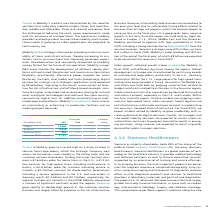According to Siemens Ag's financial document, What was the reason for the increase in the Orders at Mobility? grew to a record high on a sharp increase in volume from large orders, which the Strategic Company won across the businesses, most notably in the rolling stock and the customer services businesses.. The document states: "Orders at Mobility grew to a record high on a sharp increase in volume from large orders, which the Strategic Company won across the businesses, most ..." Also, What was the reason for the increase in the Revenue? Revenue grew slightly as double-digit growth in the customer services business was largely offset by a decline in the rail infrastructure business.. The document states: "umber of significant contracts across the regions. Revenue grew slightly as double-digit growth in the customer services business was largely offset b..." Also, What were the Severance charges in 2019? According to the financial document, 20 (in millions). The relevant text states: "(in millions of €) 2019 2018 Actual Comp...." Also, can you calculate: What was the average orders for 2019 and 2018? To answer this question, I need to perform calculations using the financial data. The calculation is: (12,894 + 11,025) / 2, which equals 11959.5 (in millions). This is based on the information: "Orders 12,894 11,025 17 % 16 % Orders 12,894 11,025 17 % 16 %..." The key data points involved are: 11,025, 12,894. Also, can you calculate: What it the increase / (decrease) in revenue from 2018 to 2019? Based on the calculation: 8,916 - 8,821, the result is 95 (in millions). This is based on the information: "Revenue 8,916 8,821 1 % 0 % Revenue 8,916 8,821 1 % 0 %..." The key data points involved are: 8,821, 8,916. Also, can you calculate: What is the increase / (decrease) in the Adjusted EBITDA margin from 2018 to 2019? Based on the calculation: 11.0% - 10.9%, the result is 0.1 (percentage). This is based on the information: "Adjusted EBITA margin 11.0 % 10.9 % Adjusted EBITA margin 11.0 % 10.9 %..." The key data points involved are: 10.9, 11.0. 